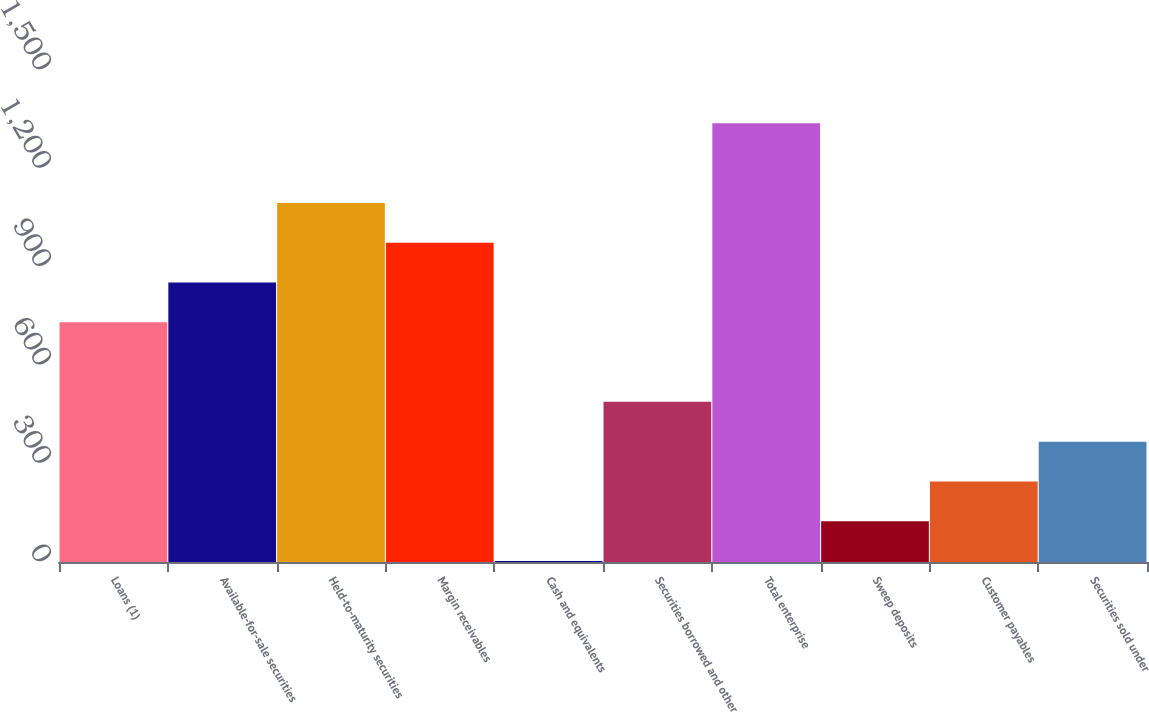<chart> <loc_0><loc_0><loc_500><loc_500><bar_chart><fcel>Loans (1)<fcel>Available-for-sale securities<fcel>Held-to-maturity securities<fcel>Margin receivables<fcel>Cash and equivalents<fcel>Securities borrowed and other<fcel>Total enterprise<fcel>Sweep deposits<fcel>Customer payables<fcel>Securities sold under<nl><fcel>730.8<fcel>852.1<fcel>1094.7<fcel>973.4<fcel>3<fcel>488.2<fcel>1337.3<fcel>124.3<fcel>245.6<fcel>366.9<nl></chart> 